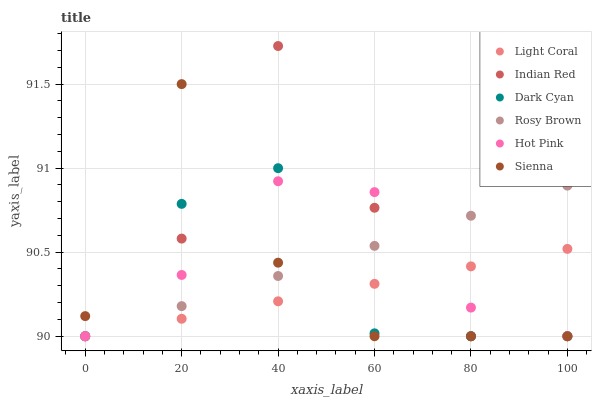Does Light Coral have the minimum area under the curve?
Answer yes or no. Yes. Does Indian Red have the maximum area under the curve?
Answer yes or no. Yes. Does Hot Pink have the minimum area under the curve?
Answer yes or no. No. Does Hot Pink have the maximum area under the curve?
Answer yes or no. No. Is Rosy Brown the smoothest?
Answer yes or no. Yes. Is Indian Red the roughest?
Answer yes or no. Yes. Is Hot Pink the smoothest?
Answer yes or no. No. Is Hot Pink the roughest?
Answer yes or no. No. Does Sienna have the lowest value?
Answer yes or no. Yes. Does Indian Red have the highest value?
Answer yes or no. Yes. Does Hot Pink have the highest value?
Answer yes or no. No. Does Dark Cyan intersect Indian Red?
Answer yes or no. Yes. Is Dark Cyan less than Indian Red?
Answer yes or no. No. Is Dark Cyan greater than Indian Red?
Answer yes or no. No. 